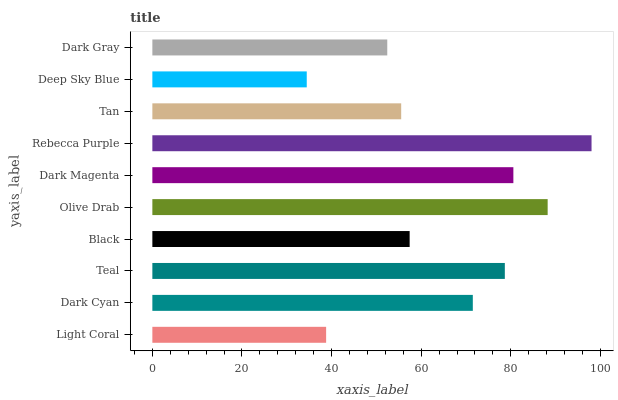Is Deep Sky Blue the minimum?
Answer yes or no. Yes. Is Rebecca Purple the maximum?
Answer yes or no. Yes. Is Dark Cyan the minimum?
Answer yes or no. No. Is Dark Cyan the maximum?
Answer yes or no. No. Is Dark Cyan greater than Light Coral?
Answer yes or no. Yes. Is Light Coral less than Dark Cyan?
Answer yes or no. Yes. Is Light Coral greater than Dark Cyan?
Answer yes or no. No. Is Dark Cyan less than Light Coral?
Answer yes or no. No. Is Dark Cyan the high median?
Answer yes or no. Yes. Is Black the low median?
Answer yes or no. Yes. Is Light Coral the high median?
Answer yes or no. No. Is Rebecca Purple the low median?
Answer yes or no. No. 